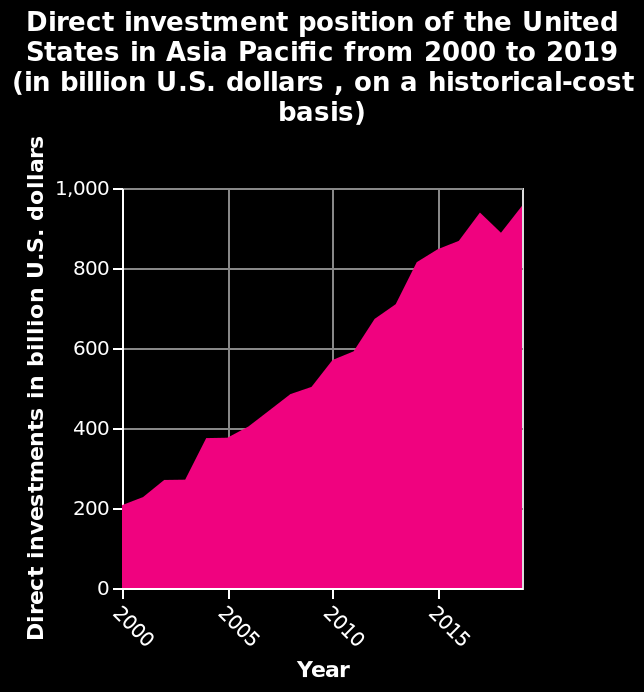<image>
Did the financial crisis of 2008 have any impact on general investment in the Asia Pacific region from the US?  No, the financial crisis of 2008 did not seem to affect general investment in the Asia Pacific region from the US. What is the title of the graph?  The title of the graph is "Direct investment position of the United States in Asia Pacific from 2000 to 2019 (in billion U.S. dollars, on a historical-cost basis)". 